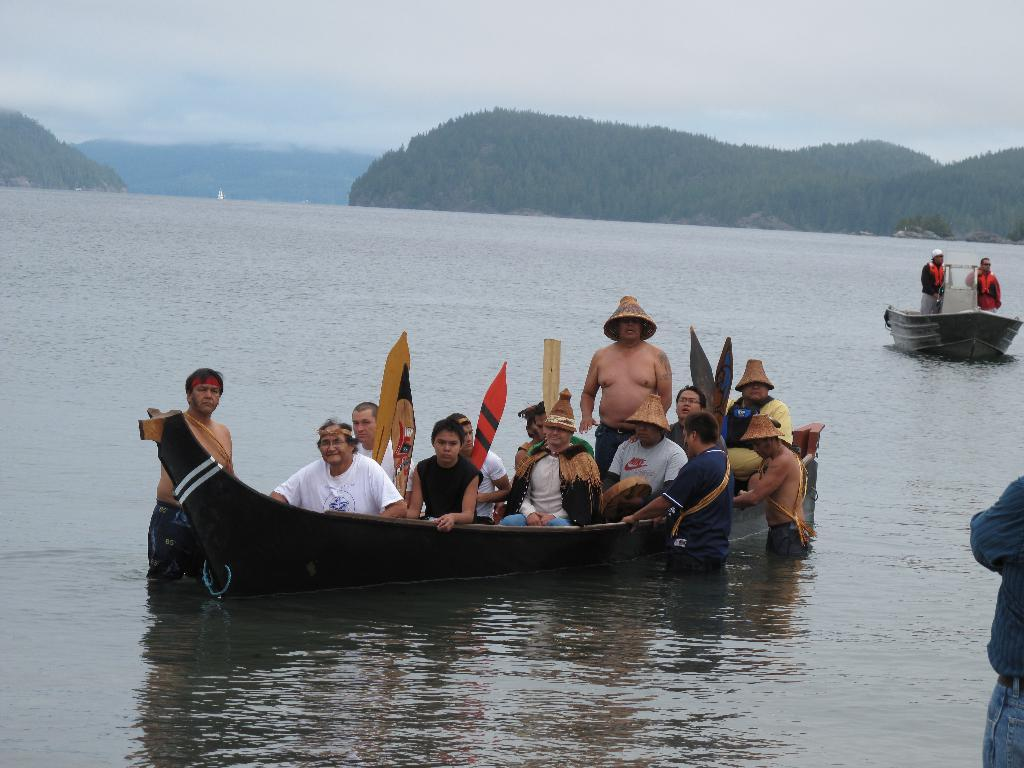What is happening in the image involving a group of people? There is a group of people in a boat. What are the people on the right side of the boat doing? Two people are standing on the right side of the boat and holding it. What can be seen in the background of the image? There are hills beside a river in the background. How would you describe the weather in the image? The sky is cloudy in the image. What type of flower can be seen growing on the boat in the image? There are no flowers visible on the boat in the image. What experience might the people in the boat be having? We cannot determine the experience of the people in the boat from the image alone. 